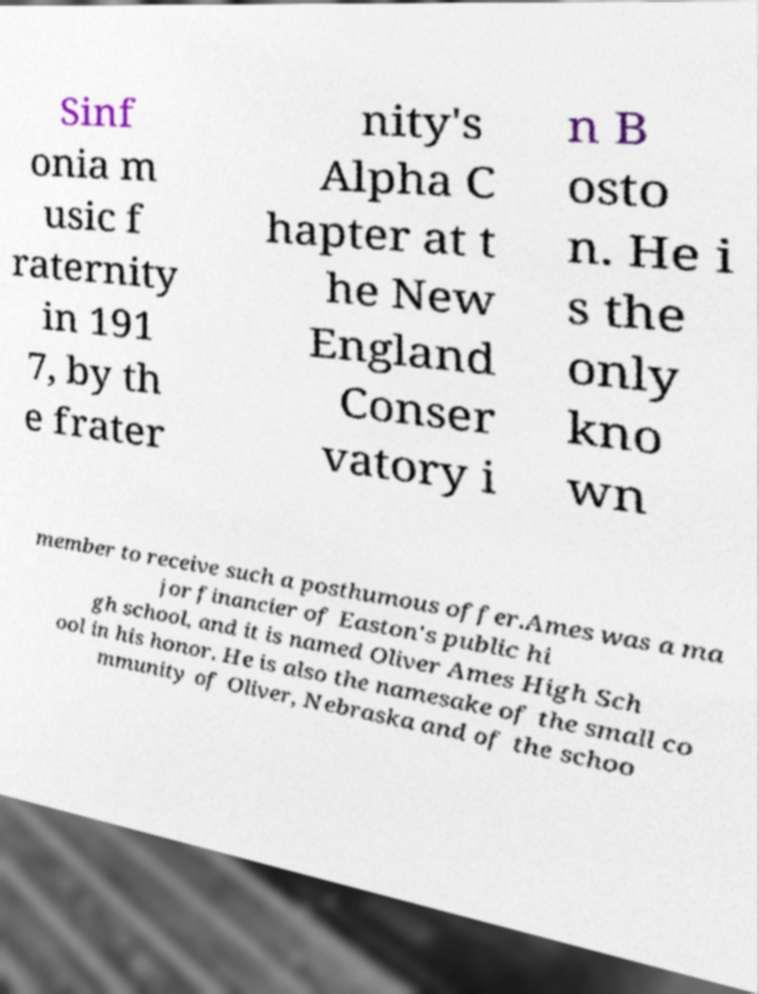Please identify and transcribe the text found in this image. Sinf onia m usic f raternity in 191 7, by th e frater nity's Alpha C hapter at t he New England Conser vatory i n B osto n. He i s the only kno wn member to receive such a posthumous offer.Ames was a ma jor financier of Easton's public hi gh school, and it is named Oliver Ames High Sch ool in his honor. He is also the namesake of the small co mmunity of Oliver, Nebraska and of the schoo 